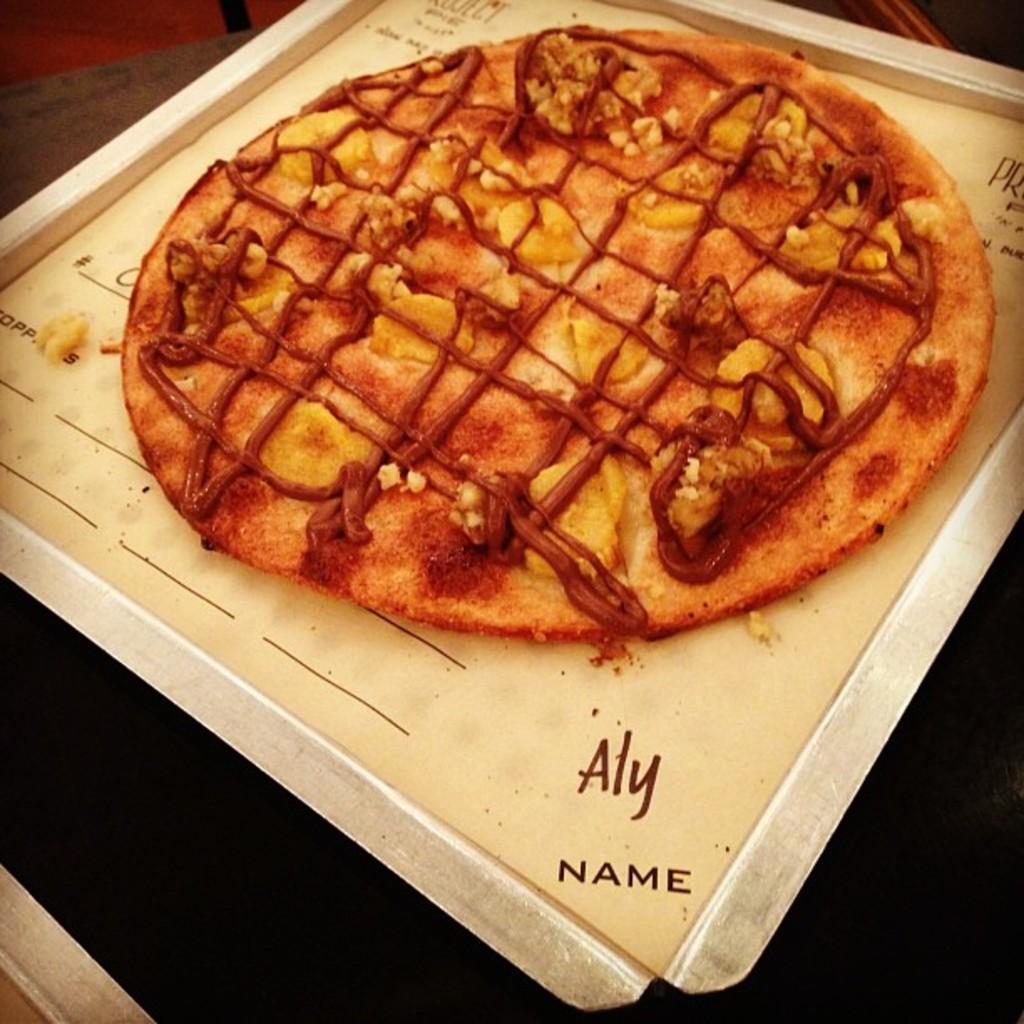In one or two sentences, can you explain what this image depicts? In this picture, we see a tray containing pizza is placed on the black table. 